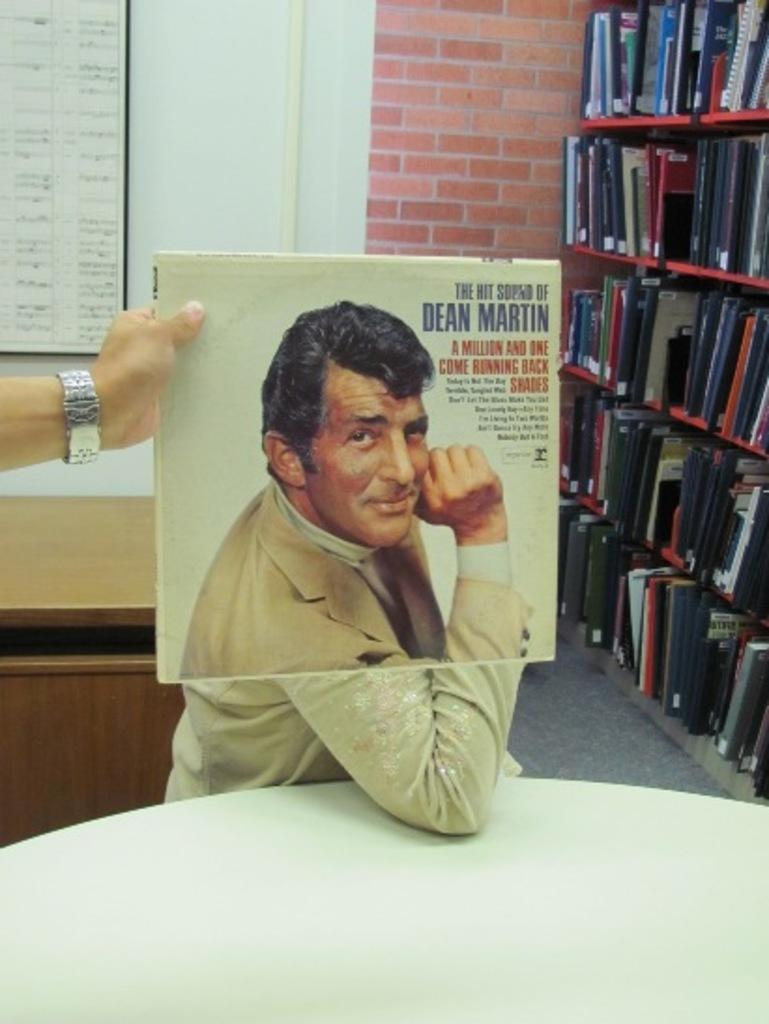<image>
Summarize the visual content of the image. Person holding an album cover that says "Dean Martin" on it. 